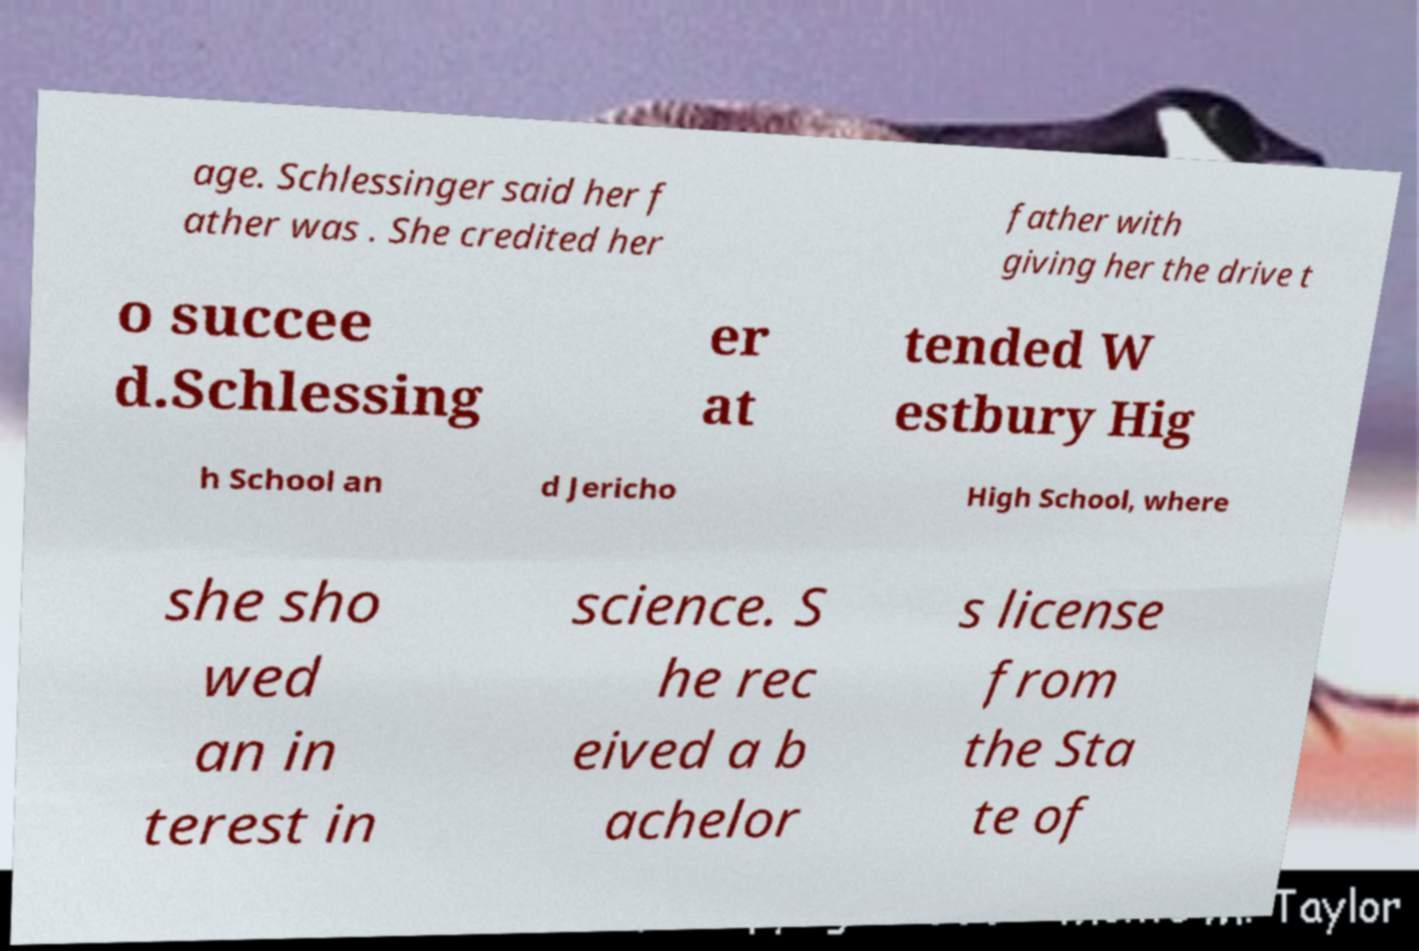Can you accurately transcribe the text from the provided image for me? age. Schlessinger said her f ather was . She credited her father with giving her the drive t o succee d.Schlessing er at tended W estbury Hig h School an d Jericho High School, where she sho wed an in terest in science. S he rec eived a b achelor s license from the Sta te of 